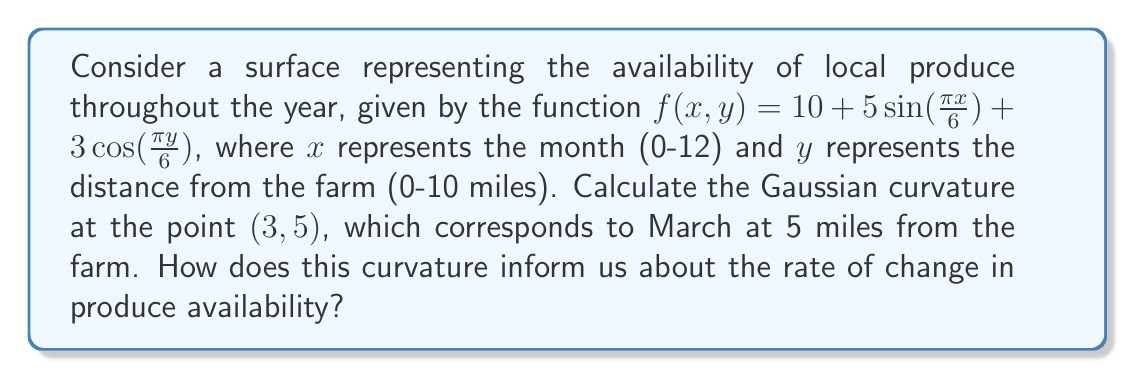Show me your answer to this math problem. To calculate the Gaussian curvature, we need to follow these steps:

1) First, we need to calculate the first and second partial derivatives:

   $f_x = \frac{5\pi}{6}\cos(\frac{\pi x}{6})$
   $f_y = -\frac{\pi}{2}\sin(\frac{\pi y}{6})$
   
   $f_{xx} = -\frac{5\pi^2}{36}\sin(\frac{\pi x}{6})$
   $f_{yy} = -\frac{\pi^2}{12}\cos(\frac{\pi y}{6})$
   $f_{xy} = f_{yx} = 0$

2) Next, we calculate these values at the point (3,5):

   $f_x(3,5) = \frac{5\pi}{6}\cos(\frac{\pi}{2}) = 0$
   $f_y(3,5) = -\frac{\pi}{2}\sin(\frac{5\pi}{6}) \approx -1.2071$
   
   $f_{xx}(3,5) = -\frac{5\pi^2}{36}\sin(\frac{\pi}{2}) = -\frac{5\pi^2}{36}$
   $f_{yy}(3,5) = -\frac{\pi^2}{12}\cos(\frac{5\pi}{6}) \approx 0.2269$
   $f_{xy}(3,5) = f_{yx}(3,5) = 0$

3) The Gaussian curvature K is given by:

   $$K = \frac{f_{xx}f_{yy} - f_{xy}^2}{(1 + f_x^2 + f_y^2)^2}$$

4) Substituting the values:

   $$K = \frac{(-\frac{5\pi^2}{36})(0.2269) - 0^2}{(1 + 0^2 + (-1.2071)^2)^2}$$

5) Simplifying:

   $$K \approx \frac{-0.0993}{(2.4571)^2} \approx -0.0164$$

The negative Gaussian curvature indicates that the surface has a saddle point at (3,5). This means that in March, at 5 miles from the farm, the produce availability is changing in opposite directions with respect to time and distance. The small magnitude suggests that these changes are relatively gradual.
Answer: $K \approx -0.0164$ 